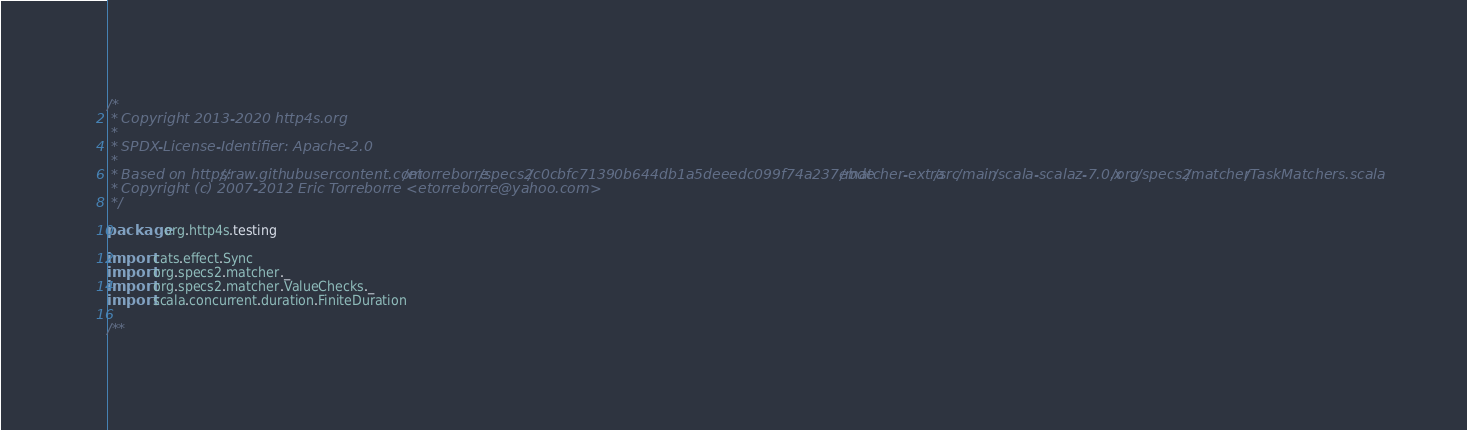<code> <loc_0><loc_0><loc_500><loc_500><_Scala_>/*
 * Copyright 2013-2020 http4s.org
 *
 * SPDX-License-Identifier: Apache-2.0
 *
 * Based on https://raw.githubusercontent.com/etorreborre/specs2/c0cbfc71390b644db1a5deeedc099f74a237ebde/matcher-extra/src/main/scala-scalaz-7.0.x/org/specs2/matcher/TaskMatchers.scala
 * Copyright (c) 2007-2012 Eric Torreborre <etorreborre@yahoo.com>
 */

package org.http4s.testing

import cats.effect.Sync
import org.specs2.matcher._
import org.specs2.matcher.ValueChecks._
import scala.concurrent.duration.FiniteDuration

/**</code> 